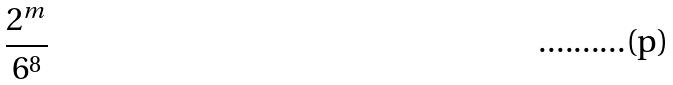Convert formula to latex. <formula><loc_0><loc_0><loc_500><loc_500>\frac { 2 ^ { m } } { 6 ^ { 8 } }</formula> 